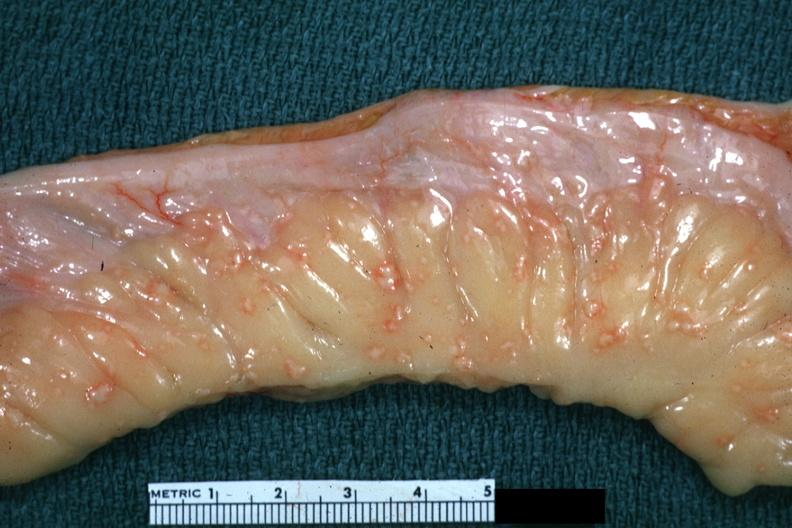s tuberculous peritonitis present?
Answer the question using a single word or phrase. No 